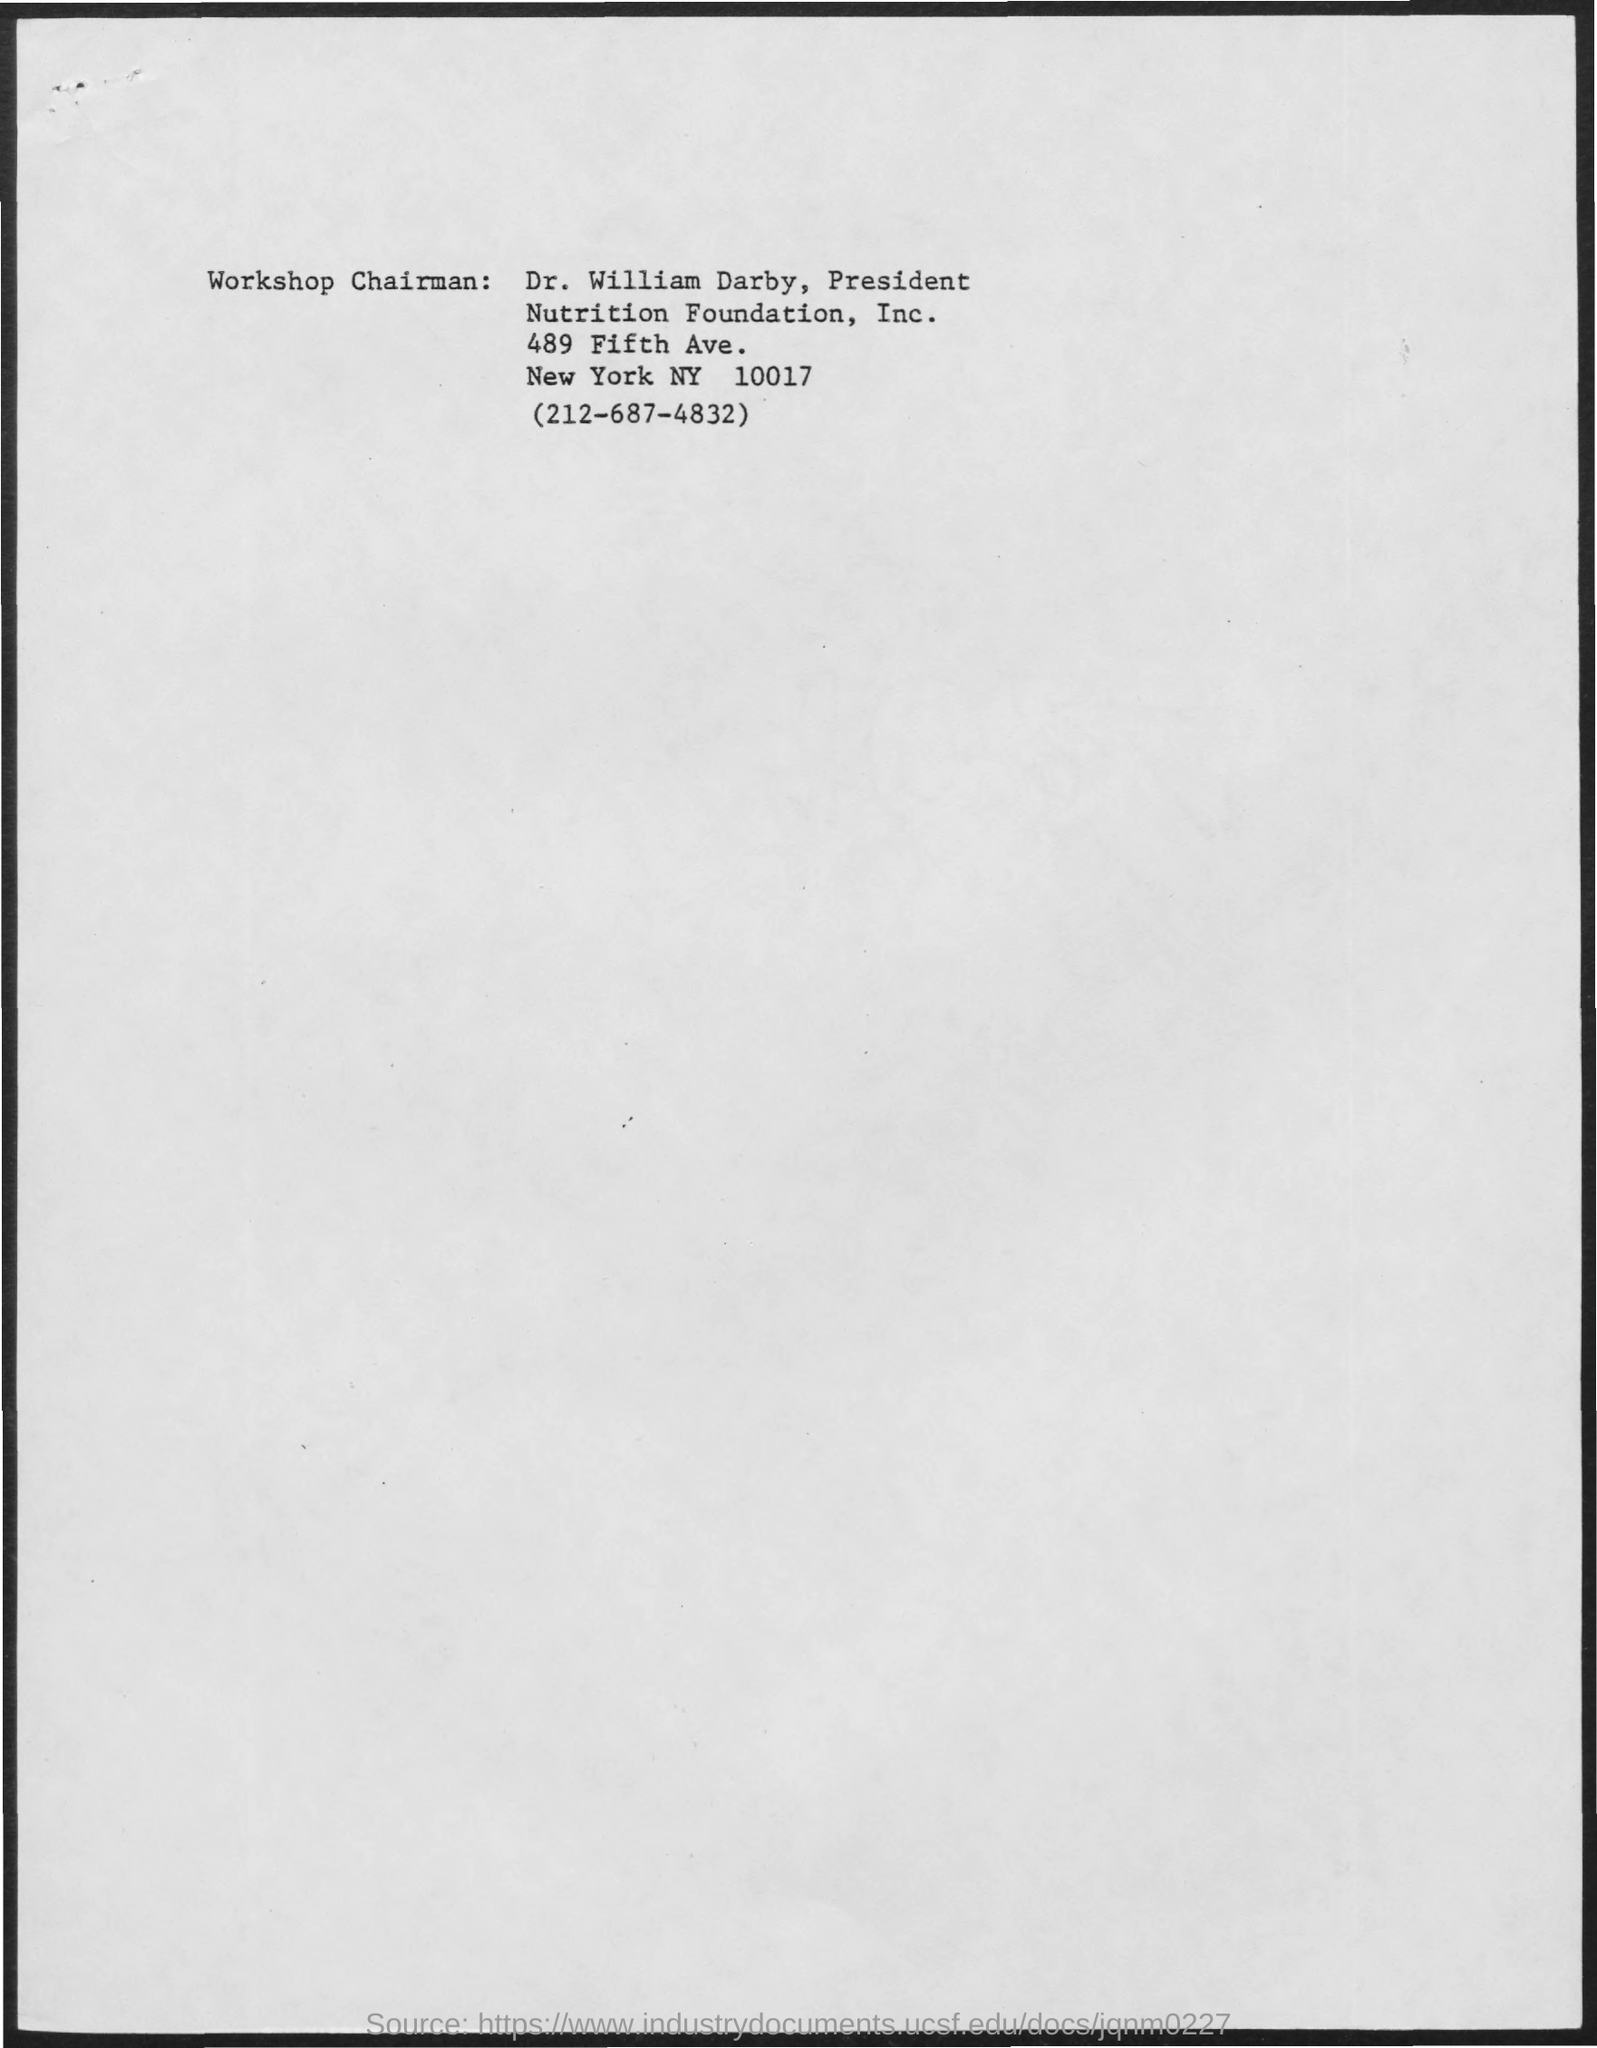List a handful of essential elements in this visual. The workshop chairman's name is Dr. William Darby. 